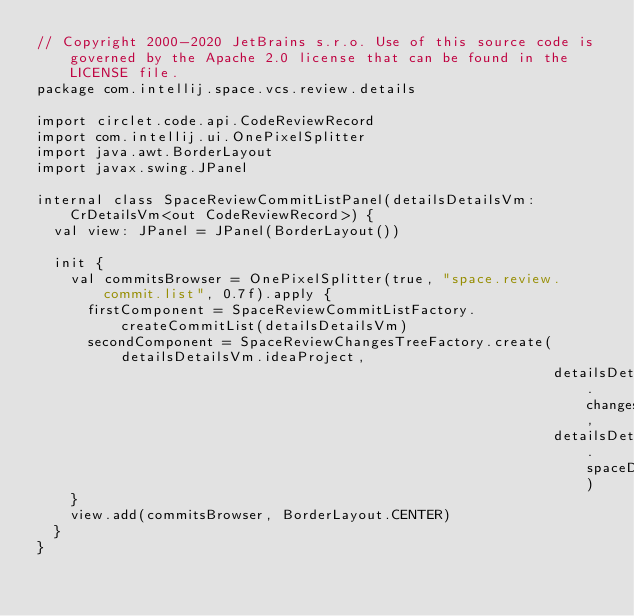Convert code to text. <code><loc_0><loc_0><loc_500><loc_500><_Kotlin_>// Copyright 2000-2020 JetBrains s.r.o. Use of this source code is governed by the Apache 2.0 license that can be found in the LICENSE file.
package com.intellij.space.vcs.review.details

import circlet.code.api.CodeReviewRecord
import com.intellij.ui.OnePixelSplitter
import java.awt.BorderLayout
import javax.swing.JPanel

internal class SpaceReviewCommitListPanel(detailsDetailsVm: CrDetailsVm<out CodeReviewRecord>) {
  val view: JPanel = JPanel(BorderLayout())

  init {
    val commitsBrowser = OnePixelSplitter(true, "space.review.commit.list", 0.7f).apply {
      firstComponent = SpaceReviewCommitListFactory.createCommitList(detailsDetailsVm)
      secondComponent = SpaceReviewChangesTreeFactory.create(detailsDetailsVm.ideaProject,
                                                             detailsDetailsVm.changesVm,
                                                             detailsDetailsVm.spaceDiffVm)
    }
    view.add(commitsBrowser, BorderLayout.CENTER)
  }
}


</code> 